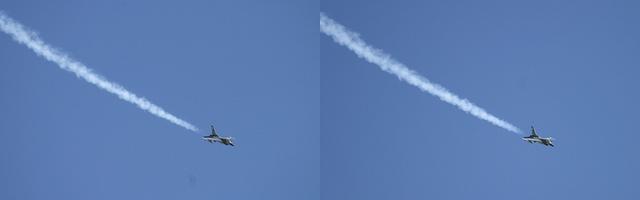What color is the sky?
Give a very brief answer. Blue. What is flying?
Short answer required. Jet. Is there a condensation trail behind the plane?
Quick response, please. Yes. 